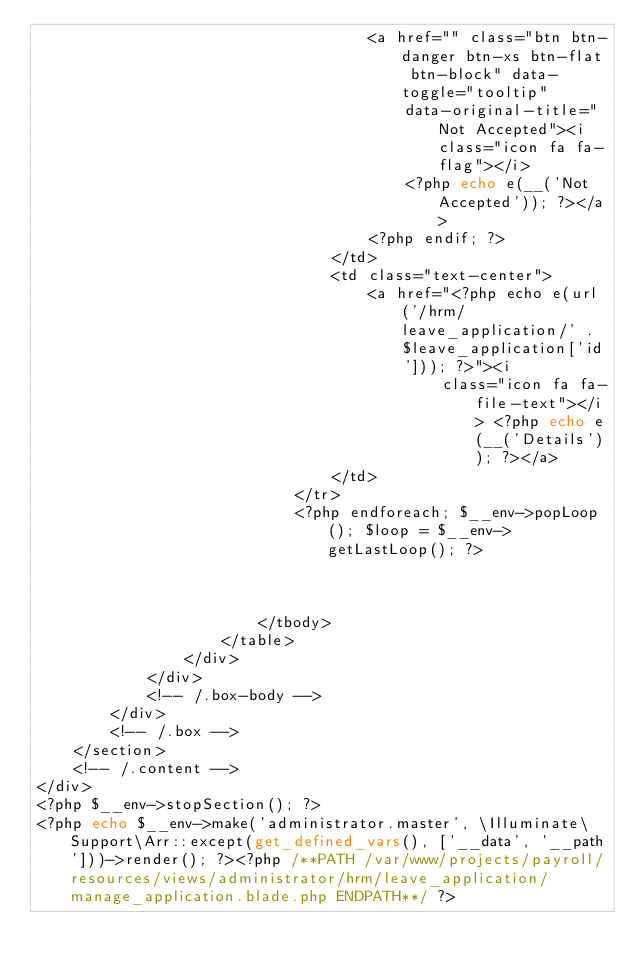Convert code to text. <code><loc_0><loc_0><loc_500><loc_500><_PHP_>                                    <a href="" class="btn btn-danger btn-xs btn-flat btn-block" data-toggle="tooltip"
                                        data-original-title="Not Accepted"><i class="icon fa fa-flag"></i>
                                        <?php echo e(__('Not Accepted')); ?></a>
                                    <?php endif; ?>
                                </td>
                                <td class="text-center">
                                    <a href="<?php echo e(url('/hrm/leave_application/' .$leave_application['id'])); ?>"><i
                                            class="icon fa fa-file-text"></i> <?php echo e(__('Details')); ?></a>
                                </td>
                            </tr>
                            <?php endforeach; $__env->popLoop(); $loop = $__env->getLastLoop(); ?>



                        </tbody>
                    </table>
                </div>
            </div>
            <!-- /.box-body -->
        </div>
        <!-- /.box -->
    </section>
    <!-- /.content -->
</div>
<?php $__env->stopSection(); ?>
<?php echo $__env->make('administrator.master', \Illuminate\Support\Arr::except(get_defined_vars(), ['__data', '__path']))->render(); ?><?php /**PATH /var/www/projects/payroll/resources/views/administrator/hrm/leave_application/manage_application.blade.php ENDPATH**/ ?></code> 